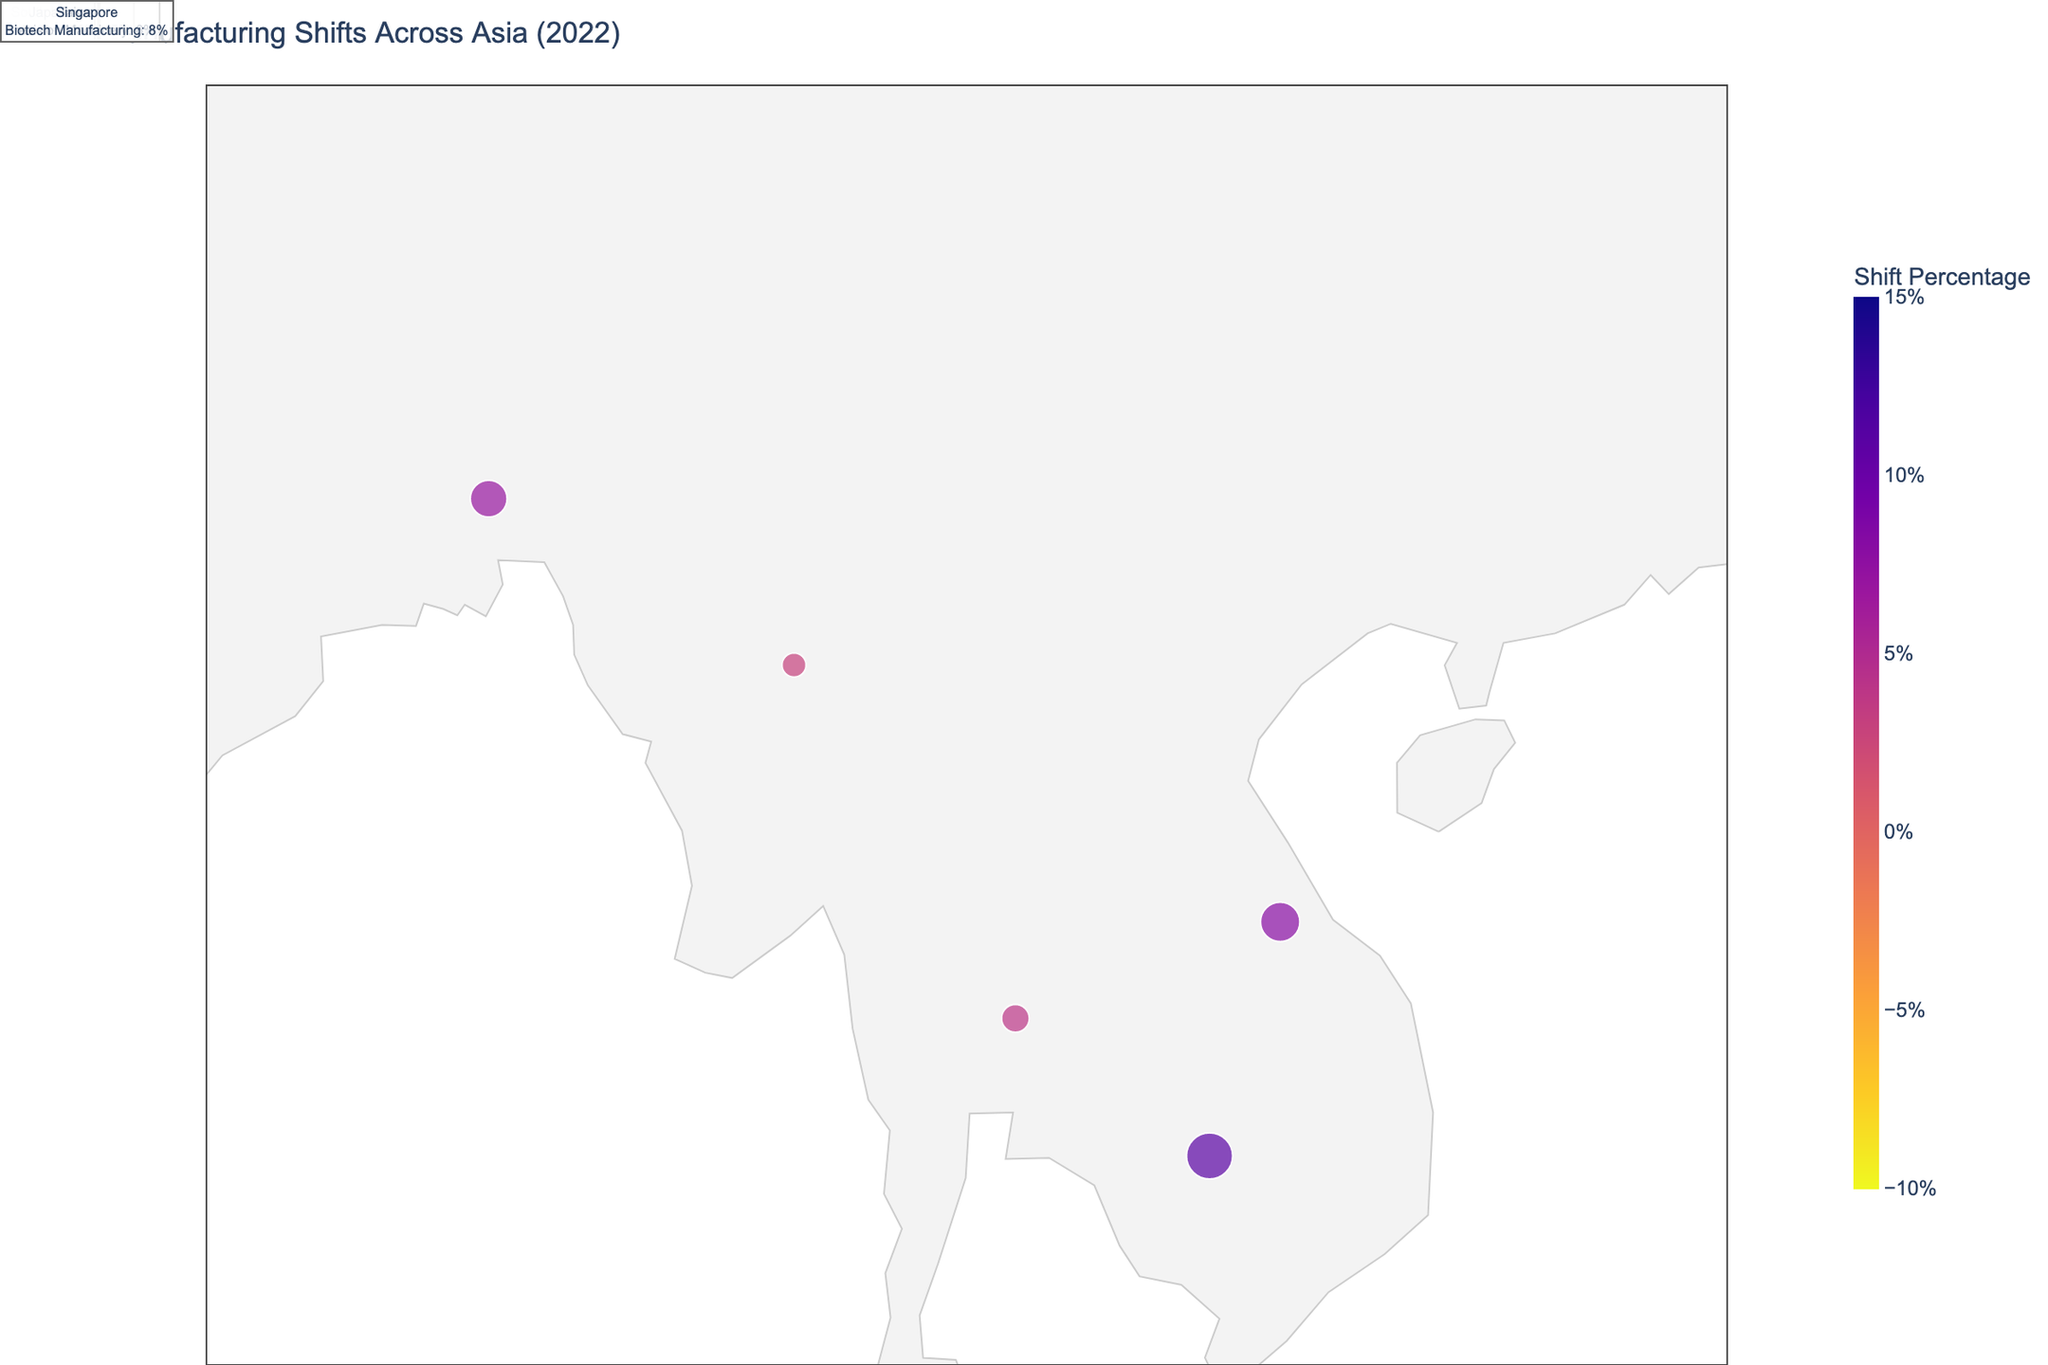Which country has the highest shift percentage in the textile industry? The figure shows data on shifts in the manufacturing sectors across Asia. From the plot, it's clear that the highest shift percentage in the textile industry can be found by comparing values for India and Bangladesh. India shows a shift of 12% in the textile industry.
Answer: India Which industry in Vietnam shows a shift in manufacturing, and what percentage shift is it? Reviewing the plotted data, industry sectors and their corresponding shift percentages are presented for each country. For Vietnam, the electronics industry shows a shift of 8%.
Answer: Electronics, 8% What is the overall shift trend for the semiconductors industry in Asia according to the plot? The data for semiconductors from the plot indicate Malaysia and the Philippines as the key players. Malaysia has a shift percentage of 9%, and the Philippines has a shift percentage of 5%. Both shifts are positive.
Answer: Positive trend, Malaysia 9%, Philippines 5% Which two countries have experienced the largest shifts in the manufacturing sector according to the plot? To find the two largest shifts, we examine all data points represented on the plot. Cambodia (11% in footwear) and India (12% in textiles) have the largest positive shifts.
Answer: India, Cambodia How does the shift in manufacturing for robotics compare between Japan and South Korea? By comparing the plotted data, South Korea has a positive shift of 10% in robotics, whereas Japan has a negative shift of -2% in the same sector.
Answer: South Korea is positive (10%), Japan is negative (-2%) What is the shift percentage for garments in Myanmar, and how does it compare to the shift percentage for biotech manufacturing in Singapore? Myanmar shows a shift of 3% in the garments sector. Singapore, on the other hand, displays an 8% shift in biotech manufacturing. Comparing these, Singapore's shift is higher.
Answer: Myanmar: 3%, Singapore: 8%, Singapore higher Which country and industry have a decline in manufacturing shift, and what is the percentage? By reviewing the data points, only China and Japan show a decline. China in the electronics sector (-5%) and Japan in the robotics sector (-2%). China has a larger decline.
Answer: China, Electronics, -5% What is the combined shift percentage for the automotive industry across the relevant countries? The automotive industry is highlighted in Thailand and Indonesia. Thailand shows a 4% shift, and Indonesia shows a 6% shift. The combined percentage is 4% + 6% = 10%.
Answer: 10% Summarize the shift trend for the electronics industry and name the countries involved. The countries involved in the electronics industry are China and Vietnam. China shows a negative shift of -5%, while Vietnam shows a positive shift of 8%, indicating a shift towards Vietnam.
Answer: Trend towards Vietnam, China -5%, Vietnam 8% How does the shift in precision machinery in Taiwan compare to the automotive shift in Thailand? Taiwan shows a positive shift of 6% in precision machinery, while Thailand shows a positive shift of 4% in the automotive sector. Taiwan's shift is greater.
Answer: Taiwan 6%, Thailand 4%, Taiwan greater 